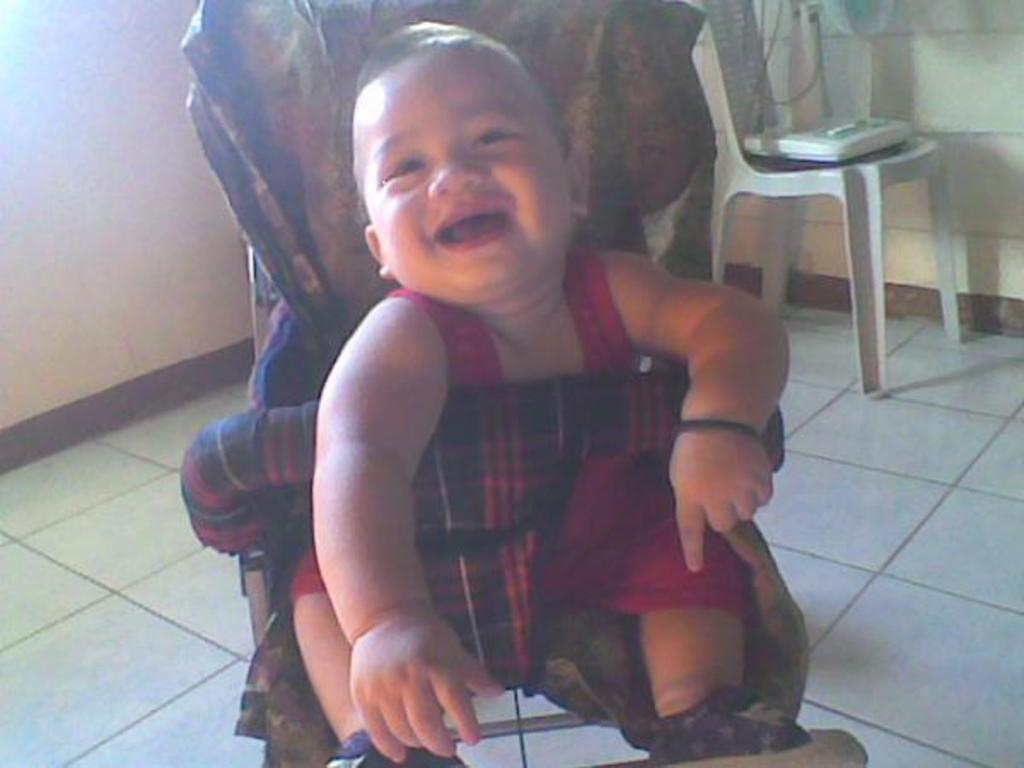What is the main subject of the image? There is a child in the image. What is the child doing in the image? The child is sitting on a chair. What is the child's facial expression in the image? The child is smiling. What type of squirrel can be seen climbing on the roof in the image? There is no squirrel or roof present in the image; it features a child sitting on a chair and smiling. What color is the thread used to sew the child's shirt in the image? There is no thread visible in the image, as it focuses on the child's face and upper body. 